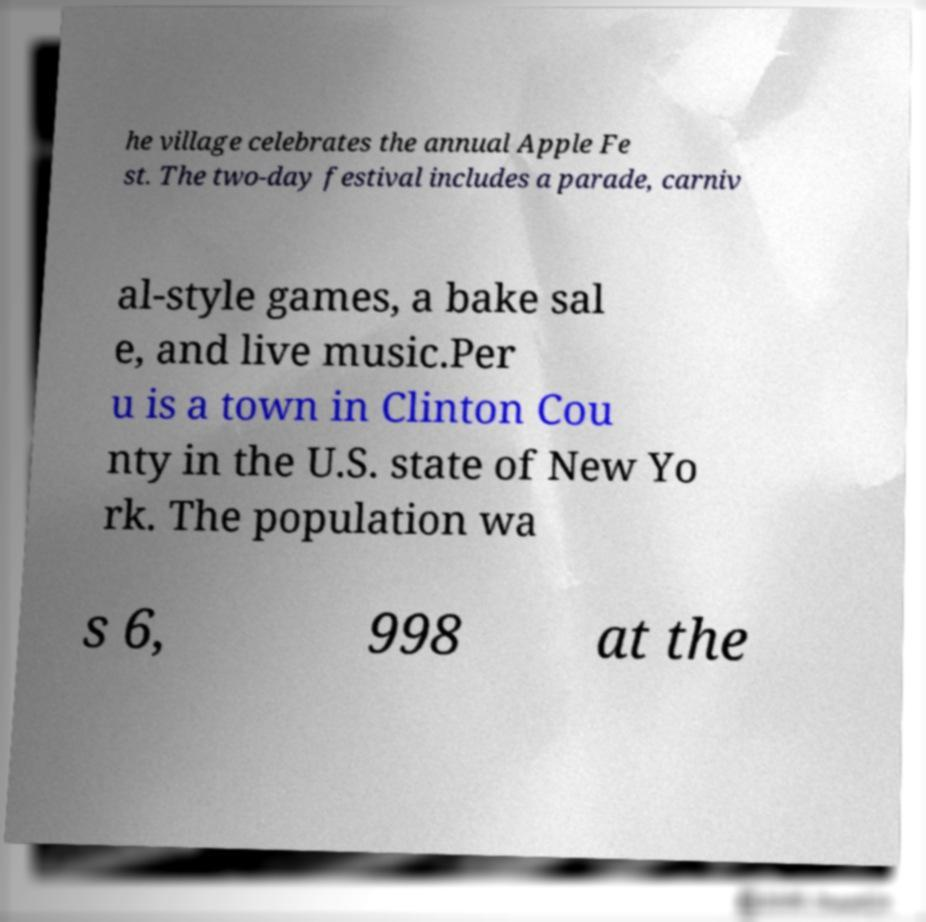What messages or text are displayed in this image? I need them in a readable, typed format. he village celebrates the annual Apple Fe st. The two-day festival includes a parade, carniv al-style games, a bake sal e, and live music.Per u is a town in Clinton Cou nty in the U.S. state of New Yo rk. The population wa s 6, 998 at the 